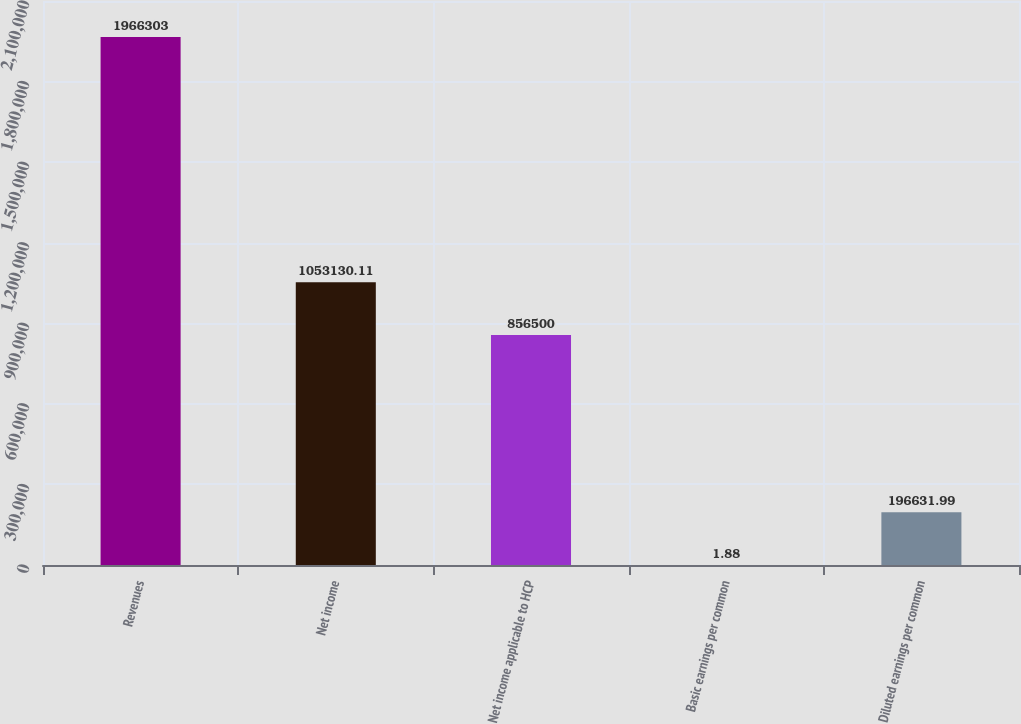<chart> <loc_0><loc_0><loc_500><loc_500><bar_chart><fcel>Revenues<fcel>Net income<fcel>Net income applicable to HCP<fcel>Basic earnings per common<fcel>Diluted earnings per common<nl><fcel>1.9663e+06<fcel>1.05313e+06<fcel>856500<fcel>1.88<fcel>196632<nl></chart> 